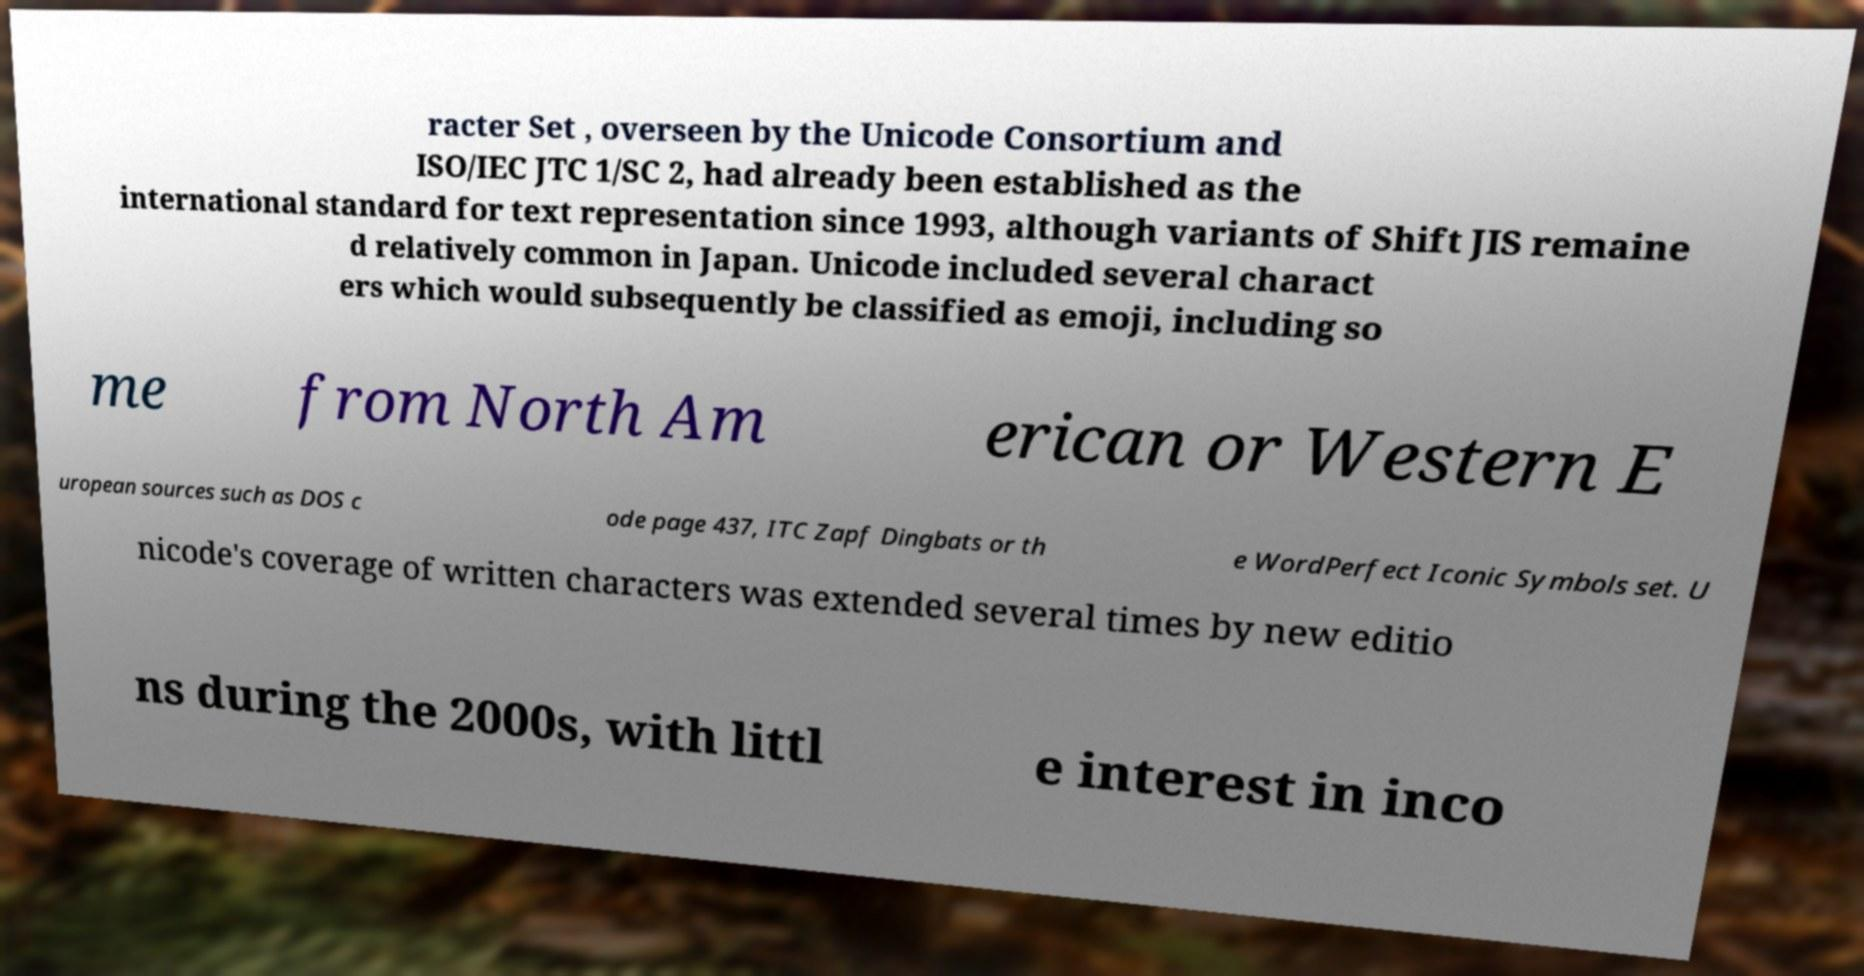Could you assist in decoding the text presented in this image and type it out clearly? racter Set , overseen by the Unicode Consortium and ISO/IEC JTC 1/SC 2, had already been established as the international standard for text representation since 1993, although variants of Shift JIS remaine d relatively common in Japan. Unicode included several charact ers which would subsequently be classified as emoji, including so me from North Am erican or Western E uropean sources such as DOS c ode page 437, ITC Zapf Dingbats or th e WordPerfect Iconic Symbols set. U nicode's coverage of written characters was extended several times by new editio ns during the 2000s, with littl e interest in inco 